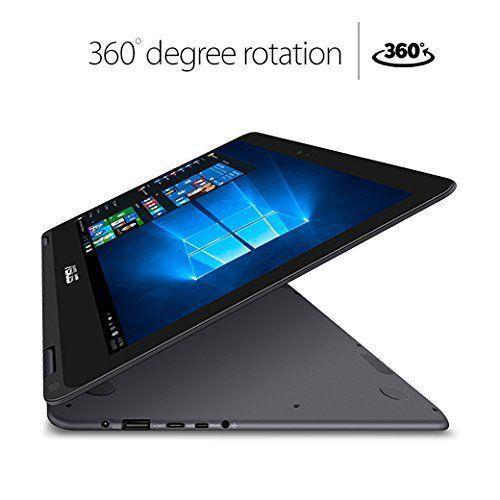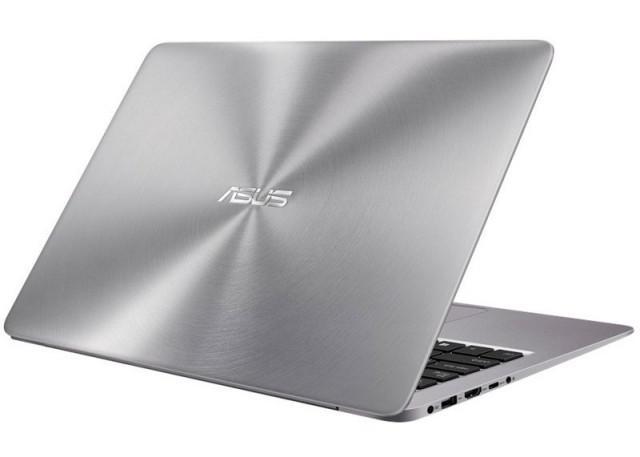The first image is the image on the left, the second image is the image on the right. Evaluate the accuracy of this statement regarding the images: "You cannot see the screen of the laptop on the right side of the image.". Is it true? Answer yes or no. Yes. 